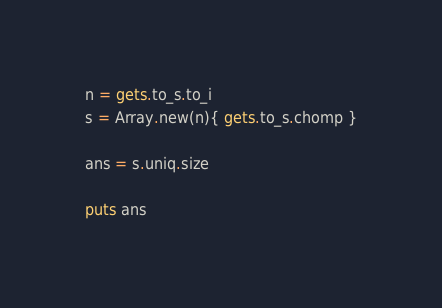Convert code to text. <code><loc_0><loc_0><loc_500><loc_500><_Crystal_>n = gets.to_s.to_i
s = Array.new(n){ gets.to_s.chomp }

ans = s.uniq.size

puts ans</code> 